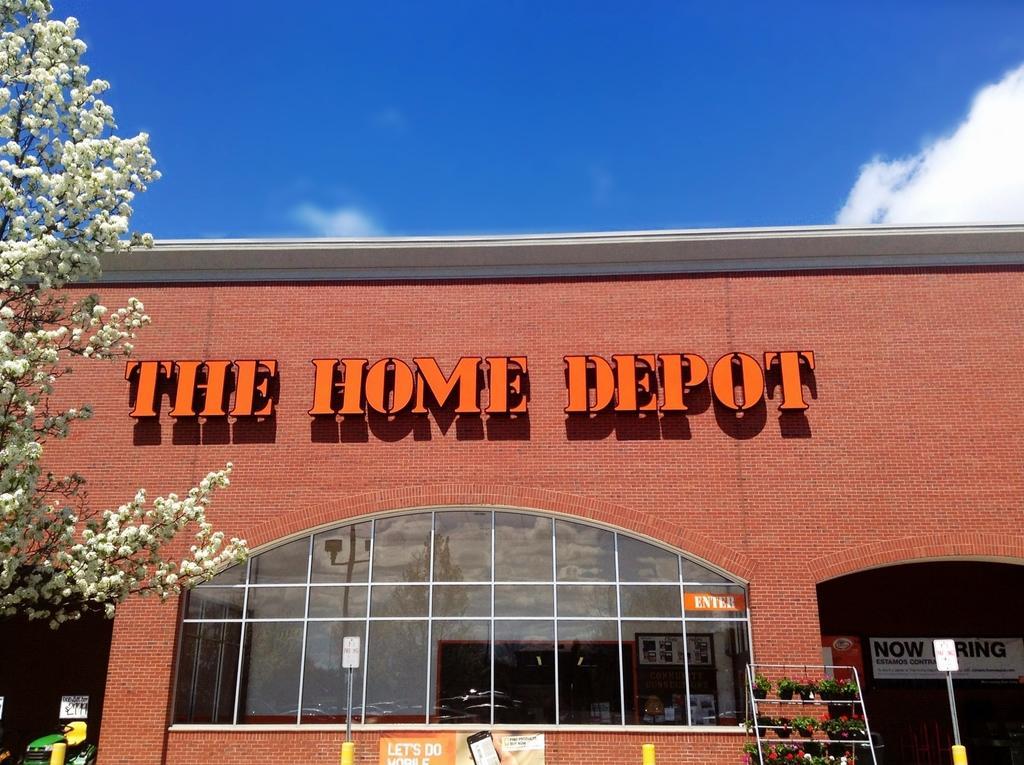Describe this image in one or two sentences. In this image we can see the brick building, flower pots placed on the stand, we can see boards, name board, glass windows, we can see the trees and the blue color sky with clouds in the background. 